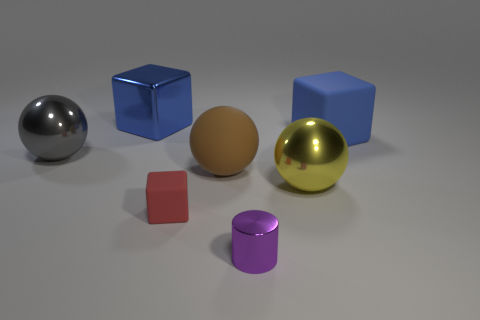Subtract all matte blocks. How many blocks are left? 1 Add 1 big purple rubber things. How many objects exist? 8 Subtract all cubes. How many objects are left? 4 Add 4 big gray cylinders. How many big gray cylinders exist? 4 Subtract 0 red balls. How many objects are left? 7 Subtract all red rubber cubes. Subtract all tiny yellow spheres. How many objects are left? 6 Add 1 big brown spheres. How many big brown spheres are left? 2 